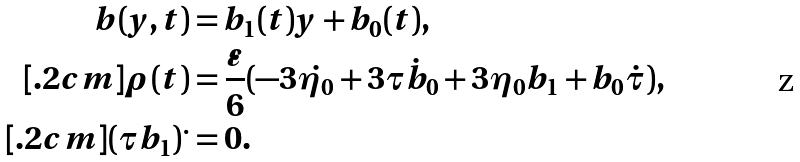Convert formula to latex. <formula><loc_0><loc_0><loc_500><loc_500>b ( y , t ) & = b _ { 1 } ( t ) y + b _ { 0 } ( t ) , \\ [ . 2 c m ] \rho ( t ) & = \frac { \varepsilon } { 6 } ( - 3 \dot { \eta _ { 0 } } + 3 \tau \dot { b } _ { 0 } + 3 \eta _ { 0 } b _ { 1 } + b _ { 0 } \dot { \tau } ) , \\ [ . 2 c m ] { ( \tau b _ { 1 } ) } ^ { . } & = 0 .</formula> 